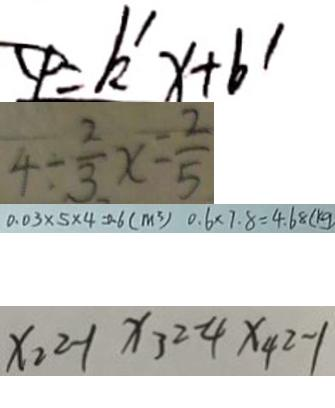<formula> <loc_0><loc_0><loc_500><loc_500>C P = k ^ { \prime } x + b ^ { \prime } 
 4 \div \frac { 2 } { 3 } x - \frac { 2 } { 5 } 
 0 . 0 3 \times 5 \times 4 = 0 . 6 ( m ^ { 3 } ) 0 . 6 \times 7 . 8 = 4 . 6 8 ( k g 
 x _ { 2 } = - 1 x _ { 3 } = - 4 x _ { 4 } = - 1</formula> 